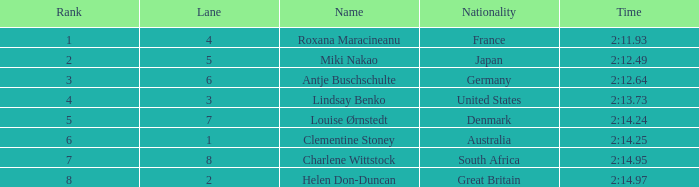What is the typical rank for an australian in a lane smaller than 3? 6.0. 